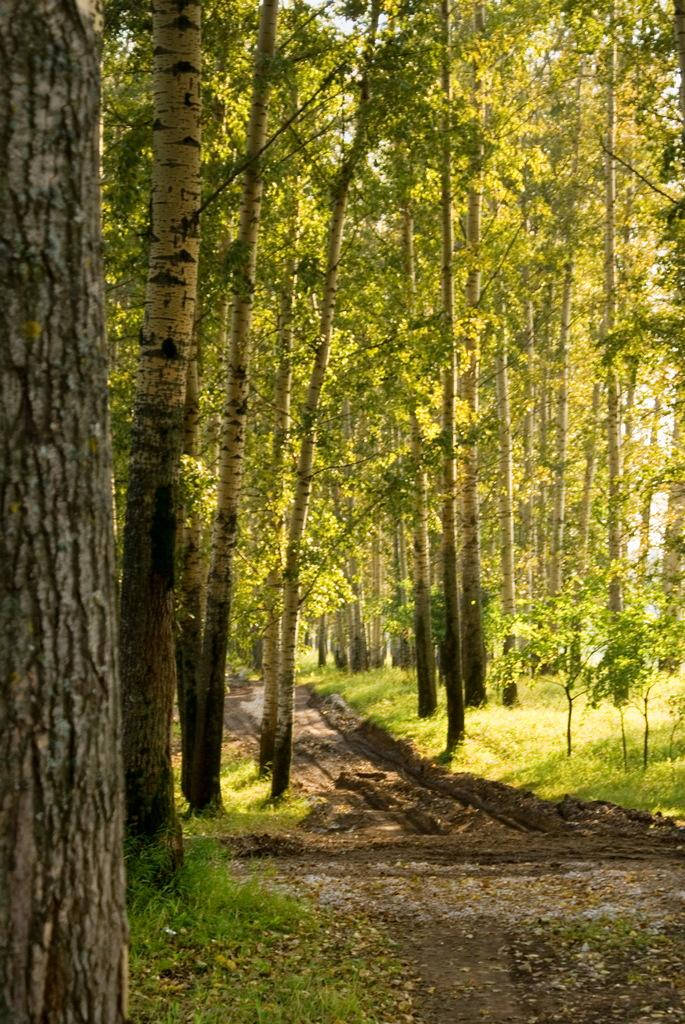What type of vegetation can be seen in the image? There are trees and grass in the image. What is on the ground in the image? There are leaves on the ground in the image. What part of the natural environment is visible in the image? The sky is visible in the image. How many dimes are scattered among the grass in the image? There are no dimes present in the image; it features trees, grass, leaves, and the sky. What grade is the teacher giving to the trees in the image? There is no teacher or grade present in the image; it is a natural scene with trees, grass, leaves, and the sky. 